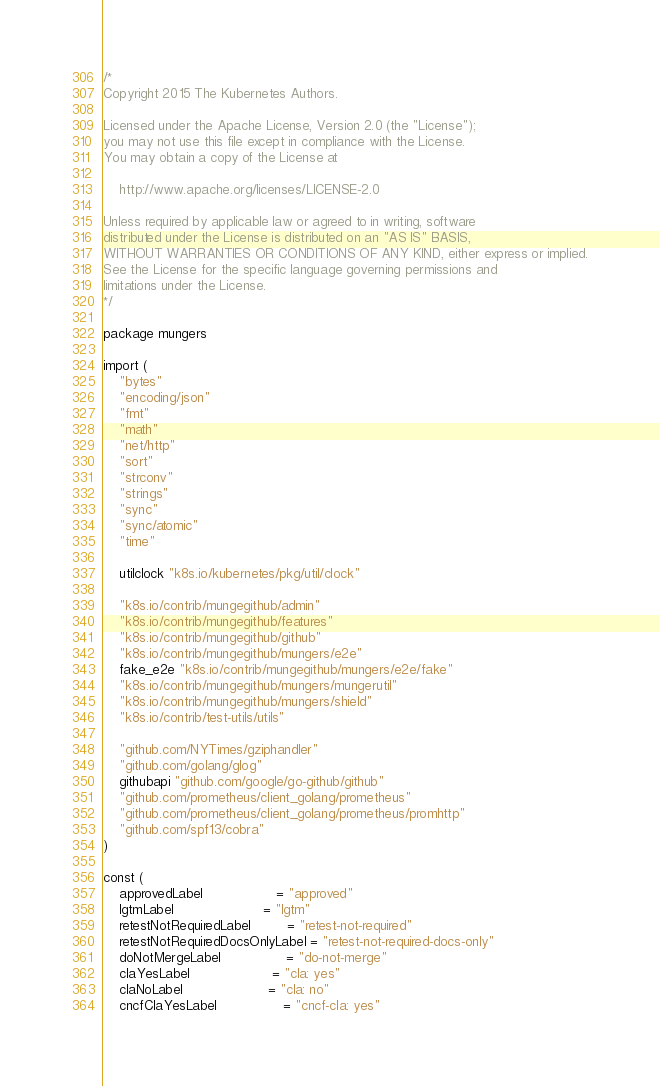<code> <loc_0><loc_0><loc_500><loc_500><_Go_>/*
Copyright 2015 The Kubernetes Authors.

Licensed under the Apache License, Version 2.0 (the "License");
you may not use this file except in compliance with the License.
You may obtain a copy of the License at

    http://www.apache.org/licenses/LICENSE-2.0

Unless required by applicable law or agreed to in writing, software
distributed under the License is distributed on an "AS IS" BASIS,
WITHOUT WARRANTIES OR CONDITIONS OF ANY KIND, either express or implied.
See the License for the specific language governing permissions and
limitations under the License.
*/

package mungers

import (
	"bytes"
	"encoding/json"
	"fmt"
	"math"
	"net/http"
	"sort"
	"strconv"
	"strings"
	"sync"
	"sync/atomic"
	"time"

	utilclock "k8s.io/kubernetes/pkg/util/clock"

	"k8s.io/contrib/mungegithub/admin"
	"k8s.io/contrib/mungegithub/features"
	"k8s.io/contrib/mungegithub/github"
	"k8s.io/contrib/mungegithub/mungers/e2e"
	fake_e2e "k8s.io/contrib/mungegithub/mungers/e2e/fake"
	"k8s.io/contrib/mungegithub/mungers/mungerutil"
	"k8s.io/contrib/mungegithub/mungers/shield"
	"k8s.io/contrib/test-utils/utils"

	"github.com/NYTimes/gziphandler"
	"github.com/golang/glog"
	githubapi "github.com/google/go-github/github"
	"github.com/prometheus/client_golang/prometheus"
	"github.com/prometheus/client_golang/prometheus/promhttp"
	"github.com/spf13/cobra"
)

const (
	approvedLabel                  = "approved"
	lgtmLabel                      = "lgtm"
	retestNotRequiredLabel         = "retest-not-required"
	retestNotRequiredDocsOnlyLabel = "retest-not-required-docs-only"
	doNotMergeLabel                = "do-not-merge"
	claYesLabel                    = "cla: yes"
	claNoLabel                     = "cla: no"
	cncfClaYesLabel                = "cncf-cla: yes"</code> 